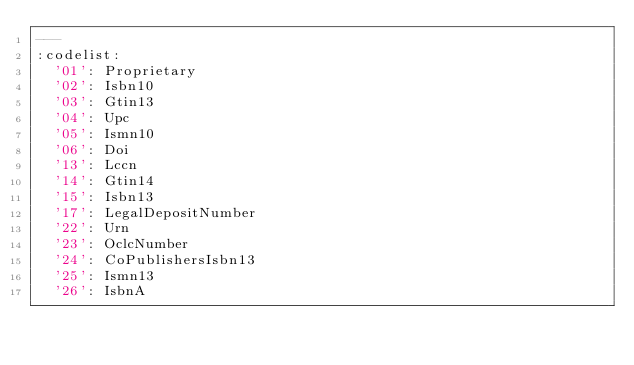<code> <loc_0><loc_0><loc_500><loc_500><_YAML_>---
:codelist:
  '01': Proprietary
  '02': Isbn10
  '03': Gtin13
  '04': Upc
  '05': Ismn10
  '06': Doi
  '13': Lccn
  '14': Gtin14
  '15': Isbn13
  '17': LegalDepositNumber
  '22': Urn
  '23': OclcNumber
  '24': CoPublishersIsbn13
  '25': Ismn13
  '26': IsbnA</code> 